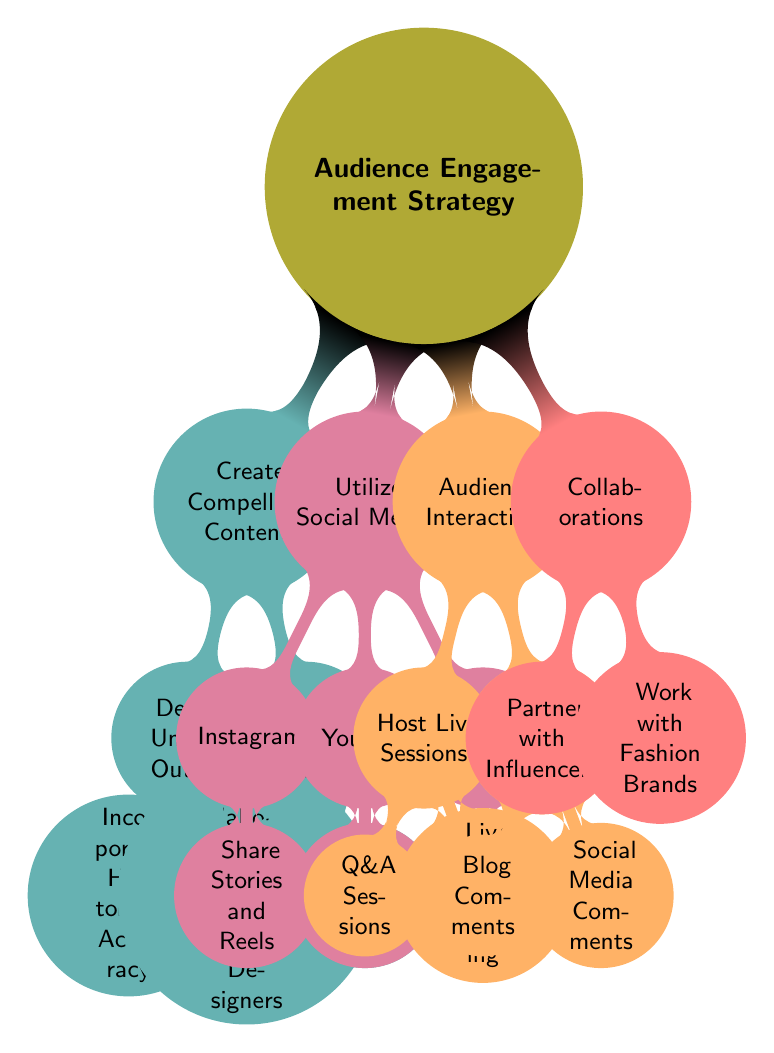What is the top node of the diagram? The top node in the diagram represents the main topic, which is "Audience Engagement Strategy."
Answer: Audience Engagement Strategy How many children does "Create Compelling Content" have? "Create Compelling Content" has two children: "Design Unique Outfits" and "Engage with Visuals." Counting these gives a total of two.
Answer: 2 Which node includes "Post Outfit Reviews"? "Post Outfit Reviews" is a child node under "YouTube," which is a part of the broader node "Utilize Social Media."
Answer: YouTube What are the two types of audience interaction listed in the diagram? The two types listed under "Audience Interaction" are "Host Live Sessions" and "Respond to Comments."
Answer: Host Live Sessions, Respond to Comments How many total nodes are there in "Collaborations"? The "Collaborations" node contains two child nodes: "Partner with Influencers" and "Work with Fashion Brands." So, counting these gives a total of two child nodes.
Answer: 2 Which node can lead to "Incorporate Historical Accuracy"? "Incorporate Historical Accuracy" is a child node under the parent node "Design Unique Outfits," which itself is a child of "Create Compelling Content."
Answer: Design Unique Outfits What children's activities are available under "Host Live Sessions"? Under "Host Live Sessions," there are two activities: "Q&A Sessions" and "Live Costume Making."
Answer: Q&A Sessions, Live Costume Making Which social media platform allows sharing stories and reels? The social media platform that allows sharing stories and reels, as shown in the diagram, is "Instagram."
Answer: Instagram What is one of the main purposes of "Utilize Social Media"? One of the main purposes is to connect with an audience through different platforms, indicated by sharing content such as outfit reviews and inspiration boards.
Answer: Connect with audience 